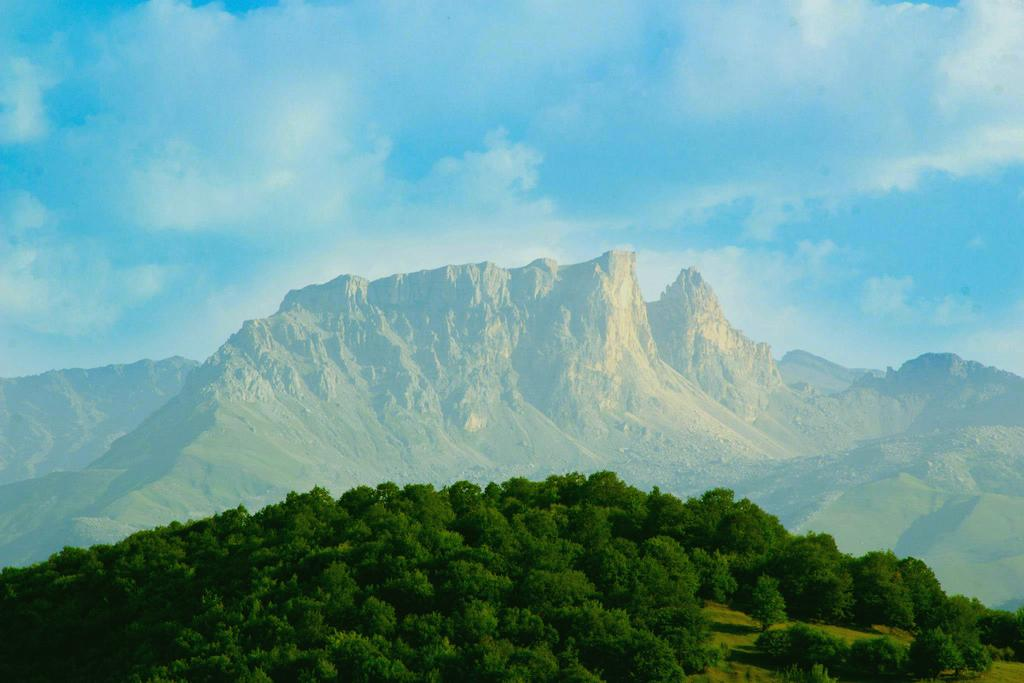What type of natural elements can be seen in the image? There are trees and mountains in the image. What is visible in the sky in the image? There are clouds in the sky. What color is the crayon used to draw the mountains in the image? There is no crayon or drawing present in the image; it is a photograph of real mountains. 